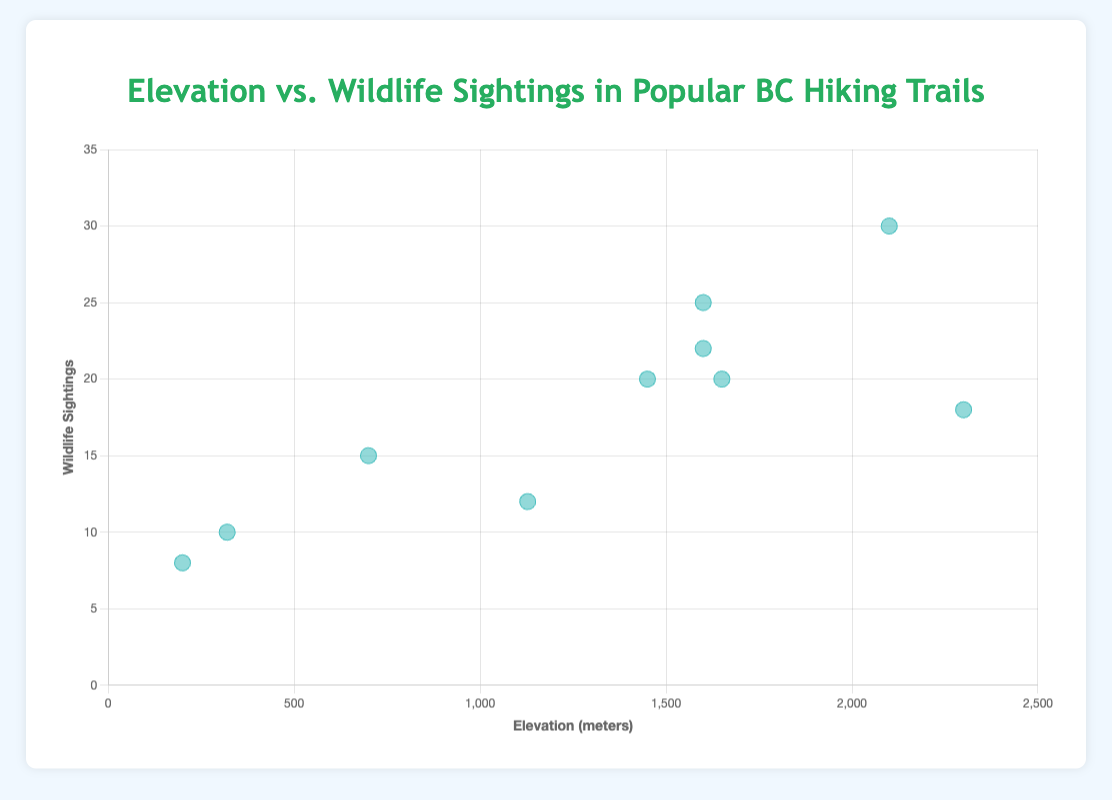What is the title of the scatter plot? The title of the plot is usually displayed at the top and is styled in a prominent way that stands out from other text elements. In the given data and code, the title is set as "Elevation vs. Wildlife Sightings in Popular BC Hiking Trails"
Answer: Elevation vs. Wildlife Sightings in Popular BC Hiking Trails How many hiking trails are represented in the scatter plot? Each data point in the scatter plot represents a hiking trail. By counting the dataset entries, we can determine the number of trails. There are 10 entries in the dataset.
Answer: 10 Which hiking trail has the highest elevation and how many wildlife sightings were recorded there? We need to find the data point with the highest elevation (x-axis value) and then check its corresponding wildlife sightings (y-axis value). In the data, "Black Tusk Trail" has the highest elevation of 2300 meters, with 18 wildlife sightings.
Answer: Black Tusk Trail, 18 Describe the color and size of the data points in the scatter plot. The data points are styled with a background color of light blue and have a prominent border in a darker shade of blue. Additionally, they have a point radius and hover radius which make them sizable and noticeable.
Answer: Light blue with dark blue borders, large size Which trail has the lowest number of wildlife sightings and what is its elevation? We look for the data point with the lowest y-axis value (wildlife sightings), which is the "Lynn Loop Trail" with 8 sightings, and its elevation is 200 meters.
Answer: Lynn Loop Trail, 200 meters What is the average number of wildlife sightings across all trails? To calculate the average, sum the wildlife sightings for all trails and divide by the number of trails. The sums are 20 + 15 + 25 + 8 + 12 + 30 + 22 + 10 + 18 + 20 = 180. There are 10 trails. The average is 180 / 10 = 18
Answer: 18 Compared to Garibaldi Lake Trail, does Black Tusk Trail have more or fewer wildlife sightings? By how many? Garibaldi Lake Trail has 20 wildlife sightings, and Black Tusk Trail has 18 sightings. To find the difference: 20 - 18 = 2. Black Tusk Trail has 2 fewer sightings.
Answer: Fewer by 2 Is there an observable trend between elevation and wildlife sightings based on the scatter plot? By visually examining the scatter plot, if we observe whether the data points tend to increase or decrease together or if there is no clear pattern. There might not be a strictly clear trend, as some higher elevation trails have fewer sightings and vice versa.
Answer: No clear trend Which trail has an elevation of 1600 meters and the highest number of wildlife sightings among trails at that elevation? There are two trails at 1600 meters: Joffre Lakes Trail and Elfin Lakes Trail. Compare their wildlife sightings: Joffre Lakes Trail has 25 sightings, and Elfin Lakes Trail has 22. The highest is Joffre Lakes Trail.
Answer: Joffre Lakes Trail, 25 Are there any trails with the same number of wildlife sightings but different elevations? Provide an example if available. Look for data points with the same y-axis value but different x-axis values. For example, "Garibaldi Lake Trail" and "Lions Binkert Trail" both have 20 wildlife sightings but different elevations, 1450 meters and 1650 meters respectively.
Answer: Garibaldi Lake Trail and Lions Binkert Trail both have 20 sightings 